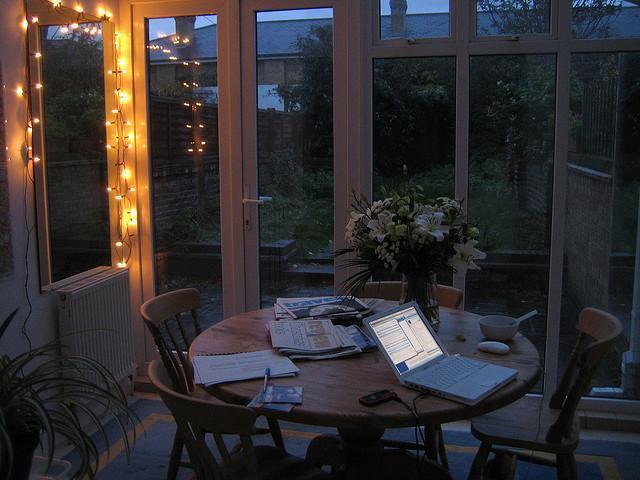How many chairs are at the table?
Give a very brief answer. 4. How many chairs can you see?
Give a very brief answer. 3. How many potted plants can be seen?
Give a very brief answer. 2. 